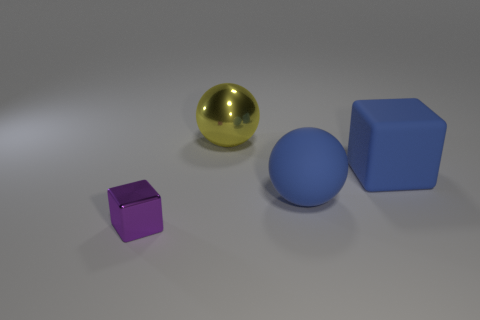Add 3 brown spheres. How many objects exist? 7 Subtract all big blue matte things. Subtract all big blue matte balls. How many objects are left? 1 Add 1 rubber cubes. How many rubber cubes are left? 2 Add 4 metallic blocks. How many metallic blocks exist? 5 Subtract 0 green cylinders. How many objects are left? 4 